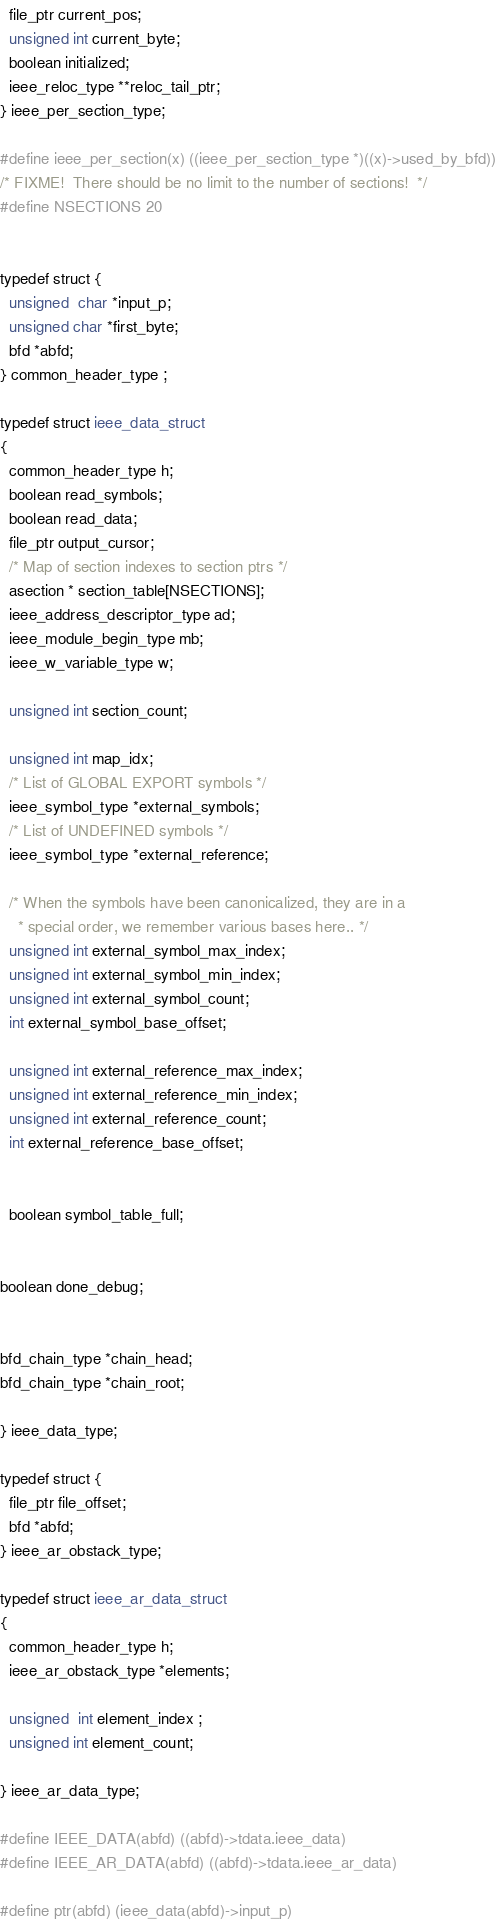<code> <loc_0><loc_0><loc_500><loc_500><_C_>  file_ptr current_pos;
  unsigned int current_byte;
  boolean initialized;
  ieee_reloc_type **reloc_tail_ptr;
} ieee_per_section_type;

#define ieee_per_section(x) ((ieee_per_section_type *)((x)->used_by_bfd))
/* FIXME!  There should be no limit to the number of sections!  */
#define NSECTIONS 20

  
typedef struct {
  unsigned  char *input_p;
  unsigned char *first_byte;
  bfd *abfd;
} common_header_type ;

typedef struct ieee_data_struct
{
  common_header_type h;
  boolean read_symbols;
  boolean read_data;	
  file_ptr output_cursor;
  /* Map of section indexes to section ptrs */
  asection * section_table[NSECTIONS];
  ieee_address_descriptor_type ad;
  ieee_module_begin_type mb;
  ieee_w_variable_type w;
  
  unsigned int section_count;
  
  unsigned int map_idx;
  /* List of GLOBAL EXPORT symbols */
  ieee_symbol_type *external_symbols;
  /* List of UNDEFINED symbols */
  ieee_symbol_type *external_reference;
  
  /* When the symbols have been canonicalized, they are in a
    * special order, we remember various bases here.. */
  unsigned int external_symbol_max_index;
  unsigned int external_symbol_min_index;
  unsigned int external_symbol_count;
  int external_symbol_base_offset;
  
  unsigned int external_reference_max_index;
  unsigned int external_reference_min_index;
  unsigned int external_reference_count;
  int external_reference_base_offset;
  

  boolean symbol_table_full;

  
boolean done_debug;


bfd_chain_type *chain_head;
bfd_chain_type *chain_root;

} ieee_data_type;

typedef struct {
  file_ptr file_offset;
  bfd *abfd;
} ieee_ar_obstack_type;

typedef struct ieee_ar_data_struct 
{
  common_header_type h;
  ieee_ar_obstack_type *elements;
  
  unsigned  int element_index ;
  unsigned int element_count;

} ieee_ar_data_type;

#define IEEE_DATA(abfd) ((abfd)->tdata.ieee_data)
#define IEEE_AR_DATA(abfd) ((abfd)->tdata.ieee_ar_data)

#define ptr(abfd) (ieee_data(abfd)->input_p)
</code> 